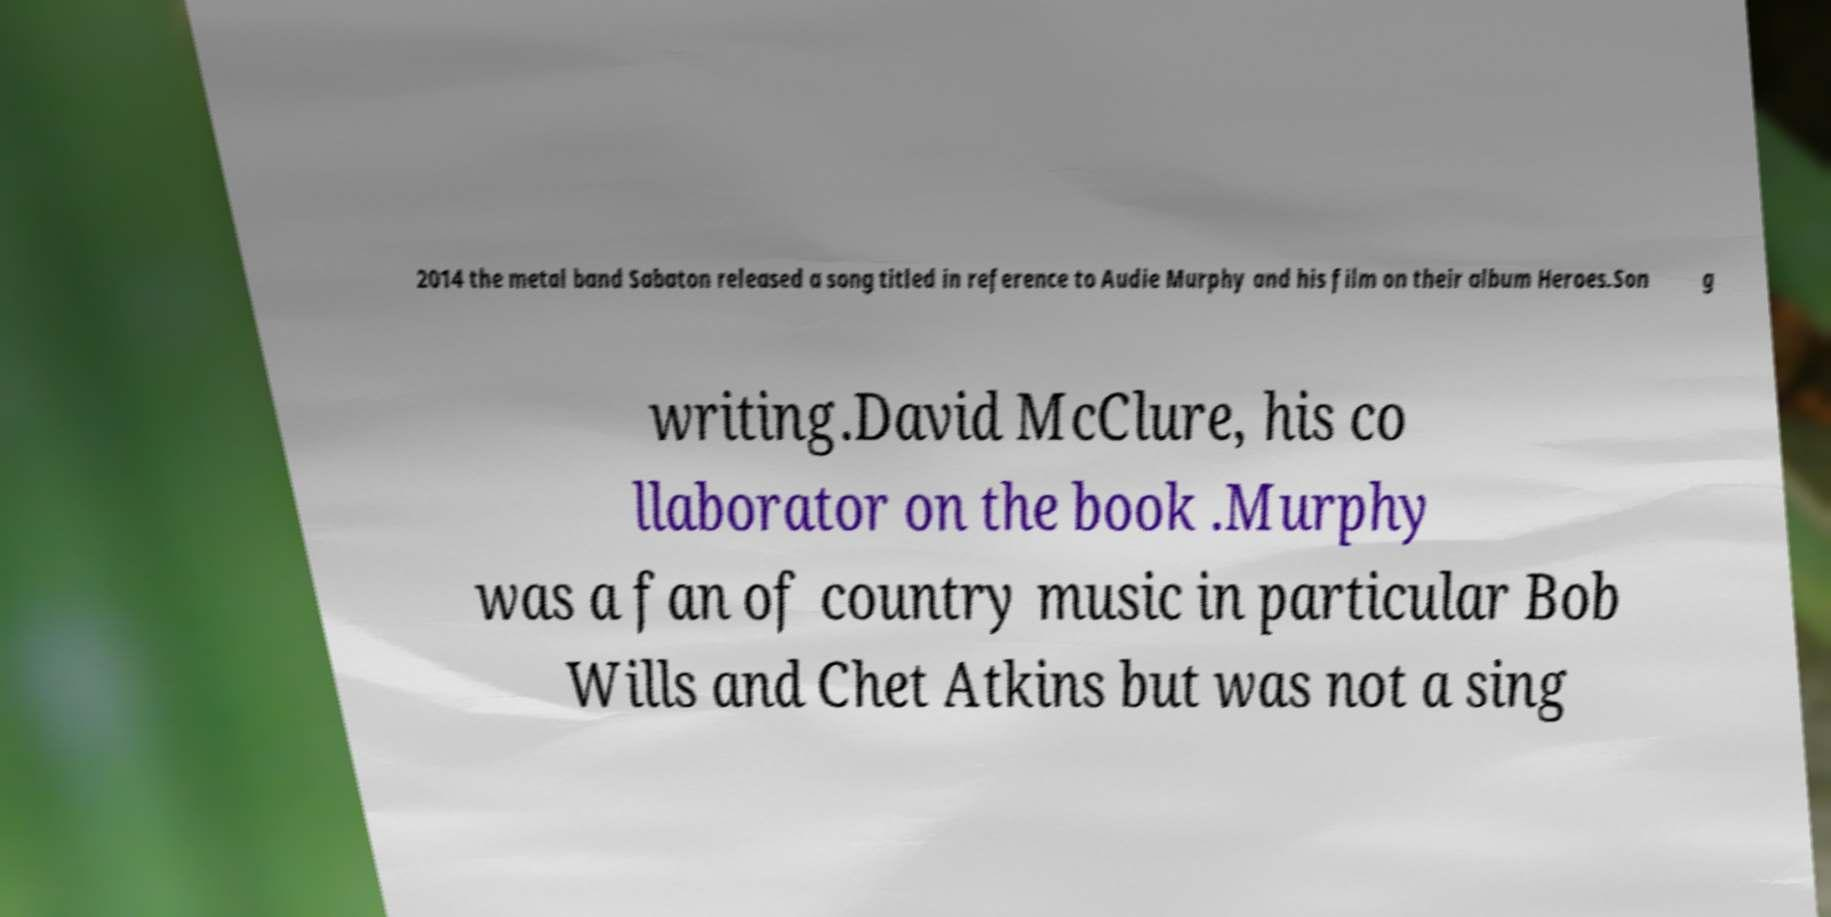Can you read and provide the text displayed in the image?This photo seems to have some interesting text. Can you extract and type it out for me? 2014 the metal band Sabaton released a song titled in reference to Audie Murphy and his film on their album Heroes.Son g writing.David McClure, his co llaborator on the book .Murphy was a fan of country music in particular Bob Wills and Chet Atkins but was not a sing 